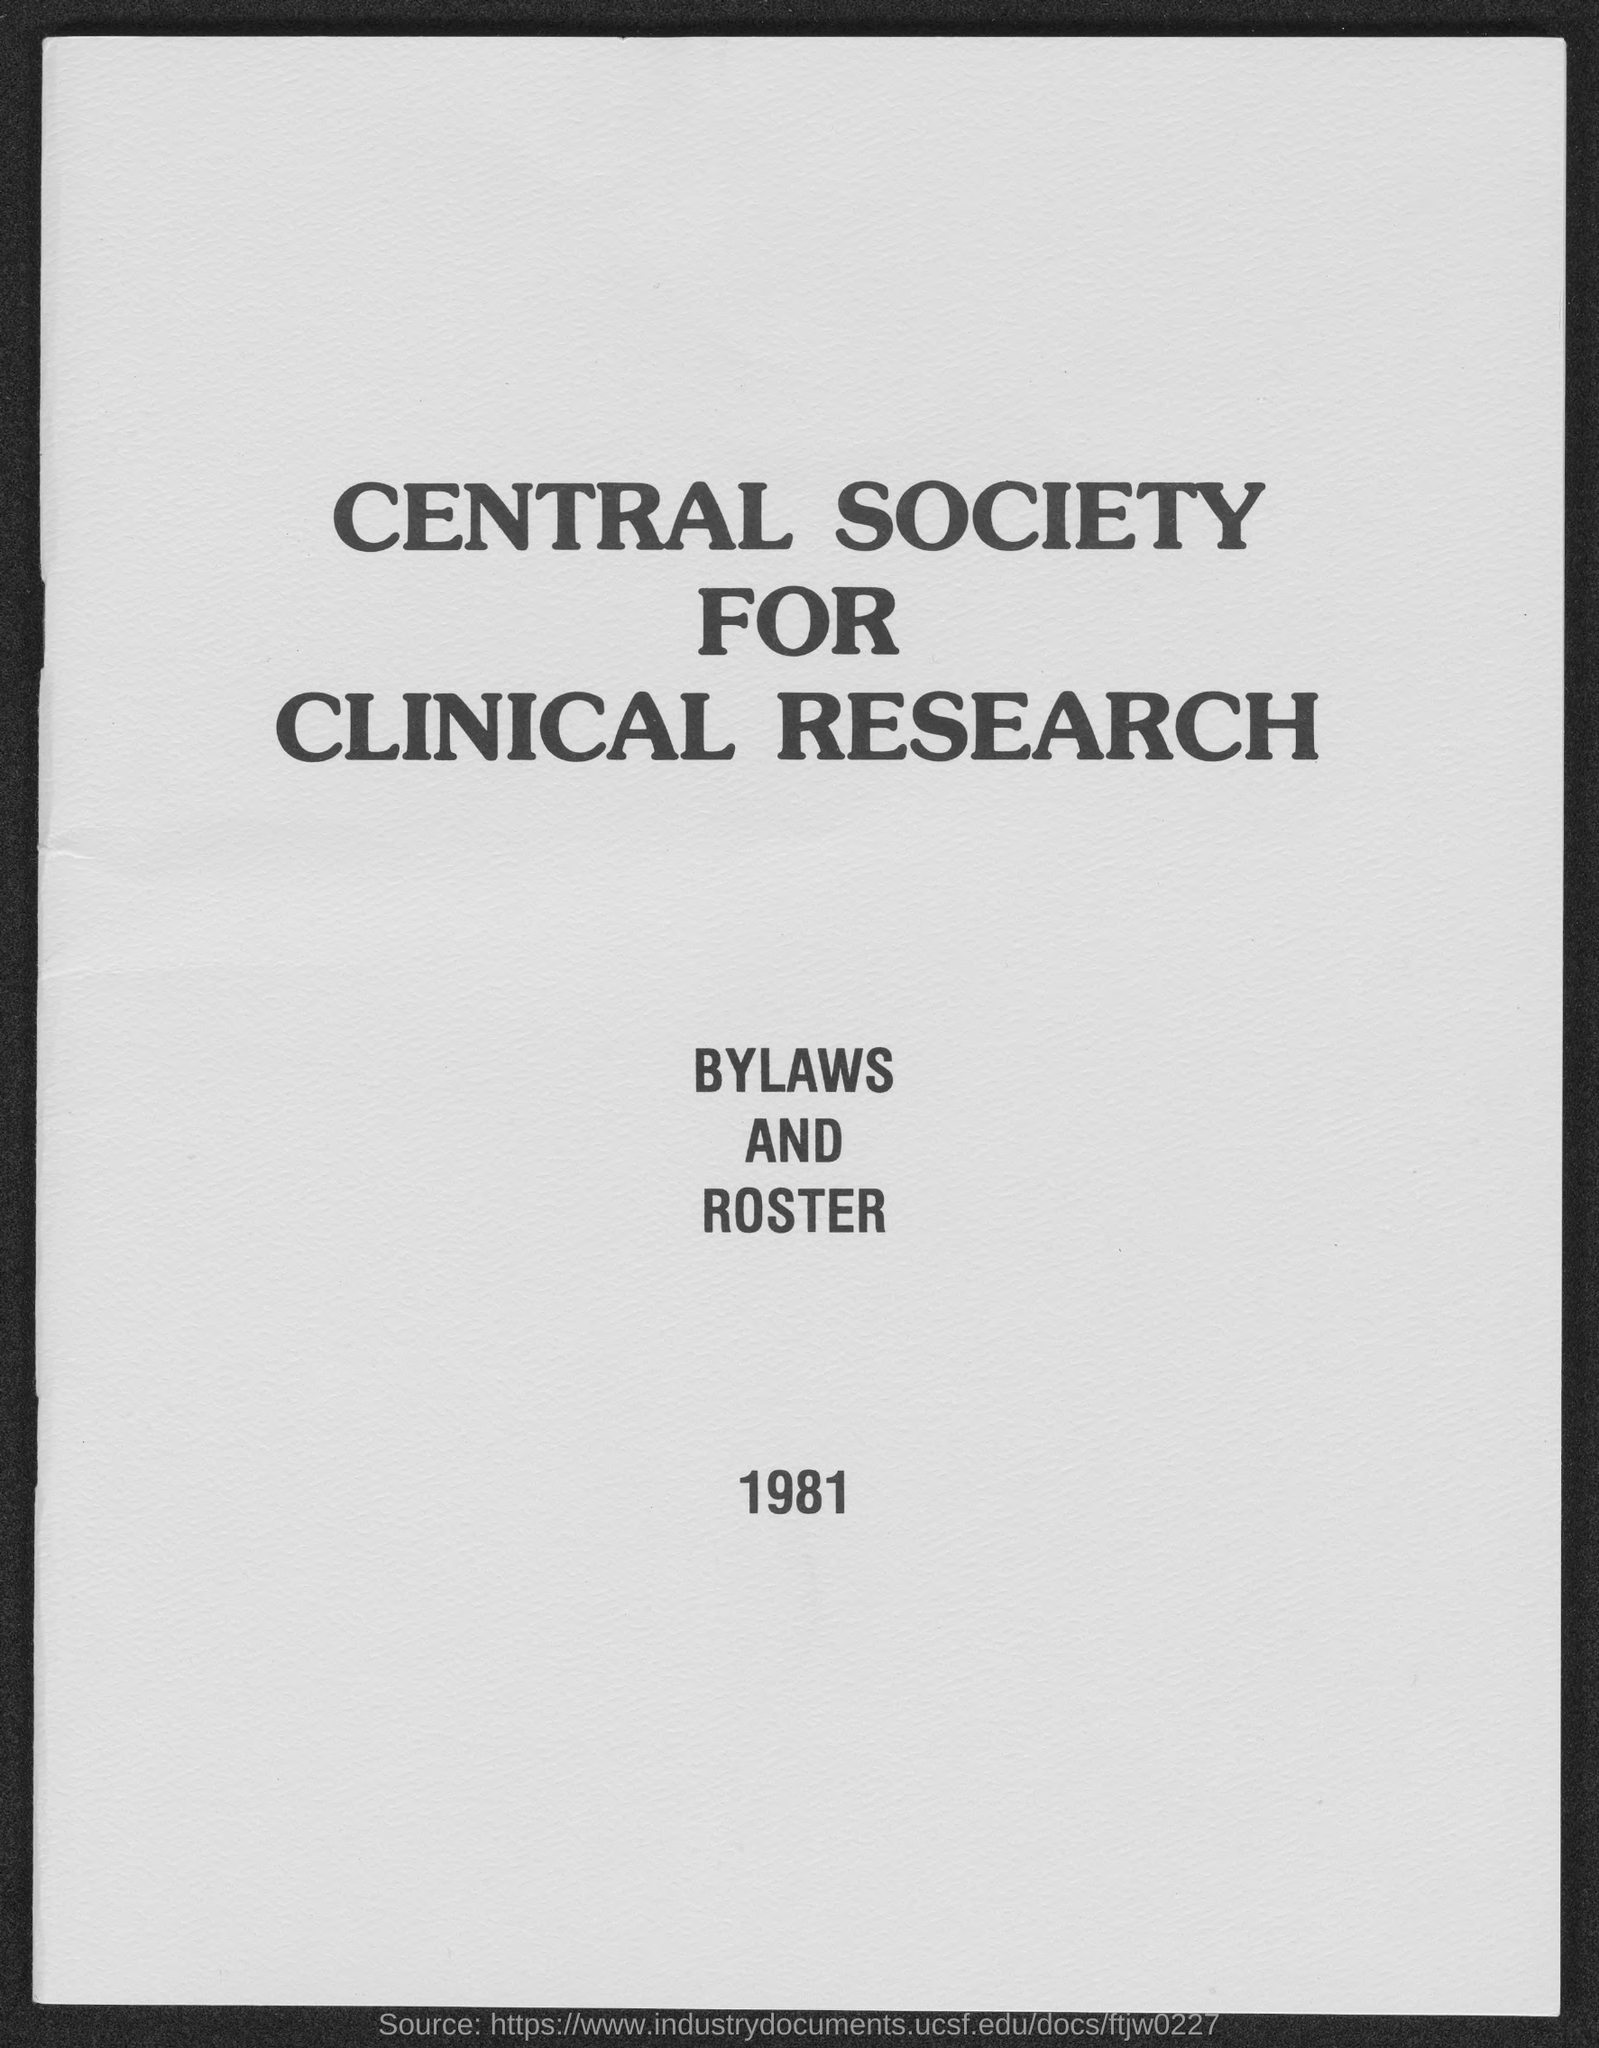Highlight a few significant elements in this photo. The Central Society for Clinical Research is a organization established for the purpose of conducting research in the field of clinical medicine. The year mentioned in the page is 1981. 